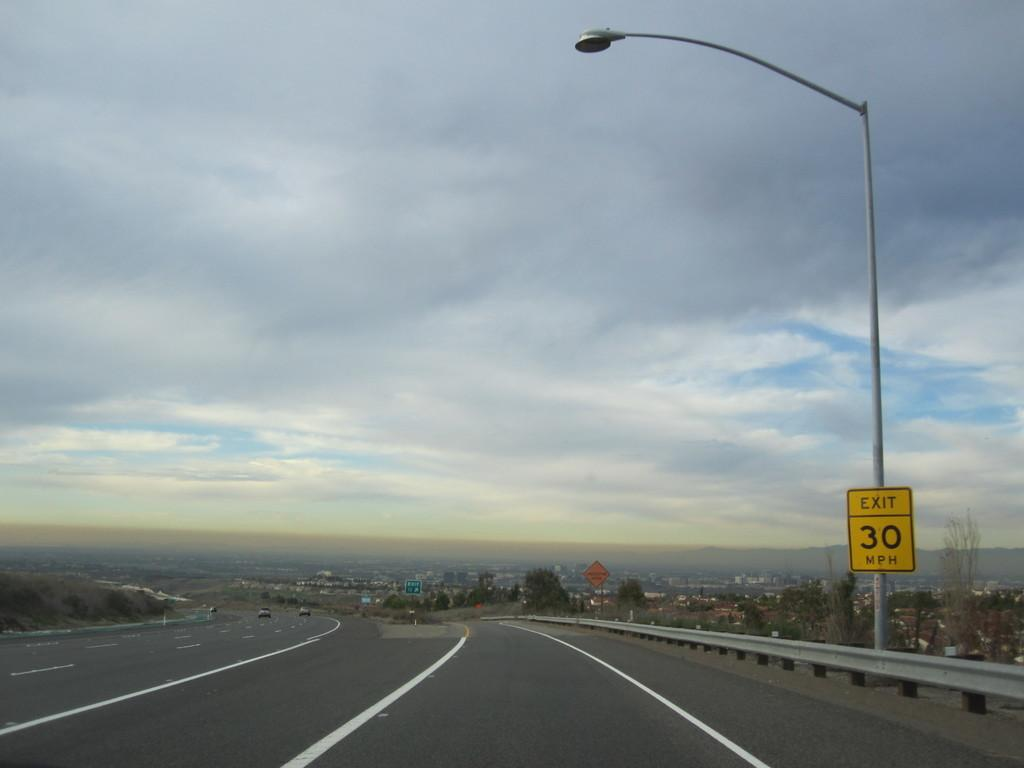What is the main feature of the image? There is a road in the image. What is attached to the pole in the image? There is a board with a light on the pole in the image. What type of structures can be seen in the image? There are buildings and houses in the image. Can you describe any other objects or features in the image? There are other unspecified things in the image. What type of scissors can be seen cutting the debt in the image? There is no mention of scissors or debt in the image; it features a road, a pole with a board and a light, buildings, houses, and other unspecified things. Is there a doll visible in the image? No, there is no doll present in the image. 